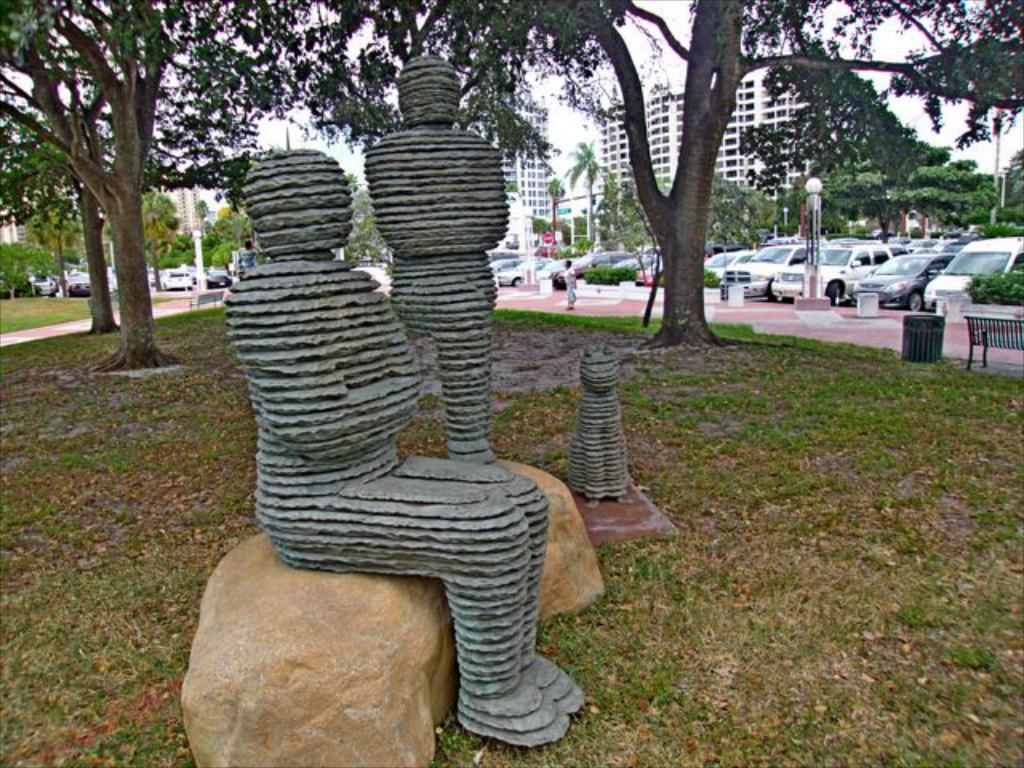Could you give a brief overview of what you see in this image? In this picture we can see there are statues and rocks. On the right side of the statues there is a bench, grass, a dustbin, plants and some vehicles are parked on the road. Behind the statues there are trees and other bench. Behind the vehicles there are buildings, poles with sign boards and the sky. 